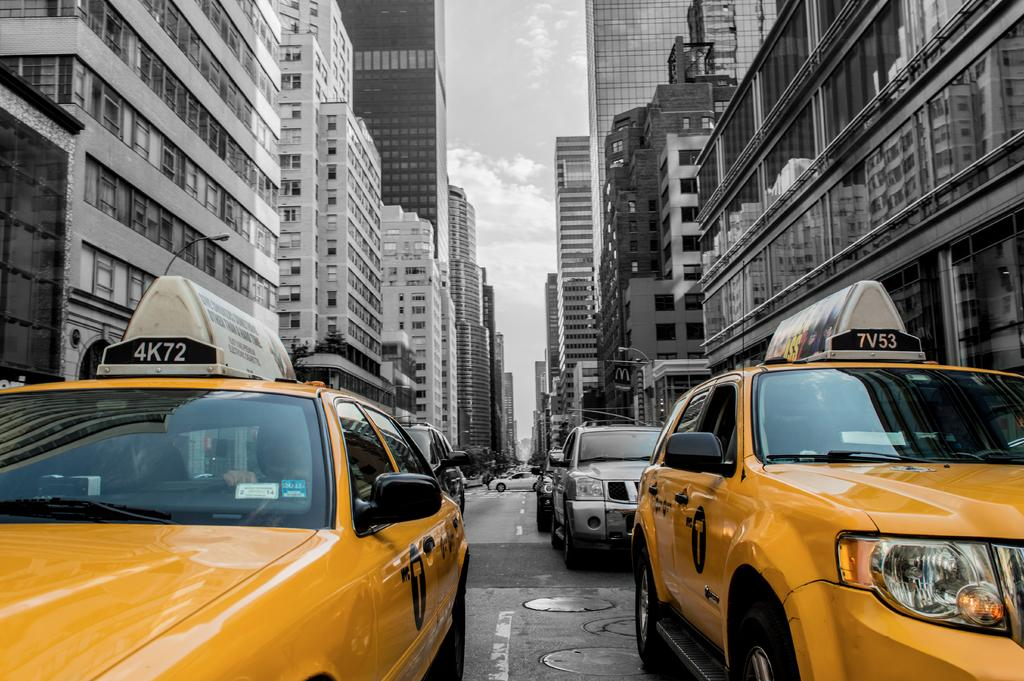<image>
Present a compact description of the photo's key features. a few cars with the numbers and letters 7V53 on it 